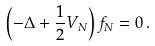Convert formula to latex. <formula><loc_0><loc_0><loc_500><loc_500>\left ( - \Delta + \frac { 1 } { 2 } V _ { N } \right ) f _ { N } = 0 \, .</formula> 